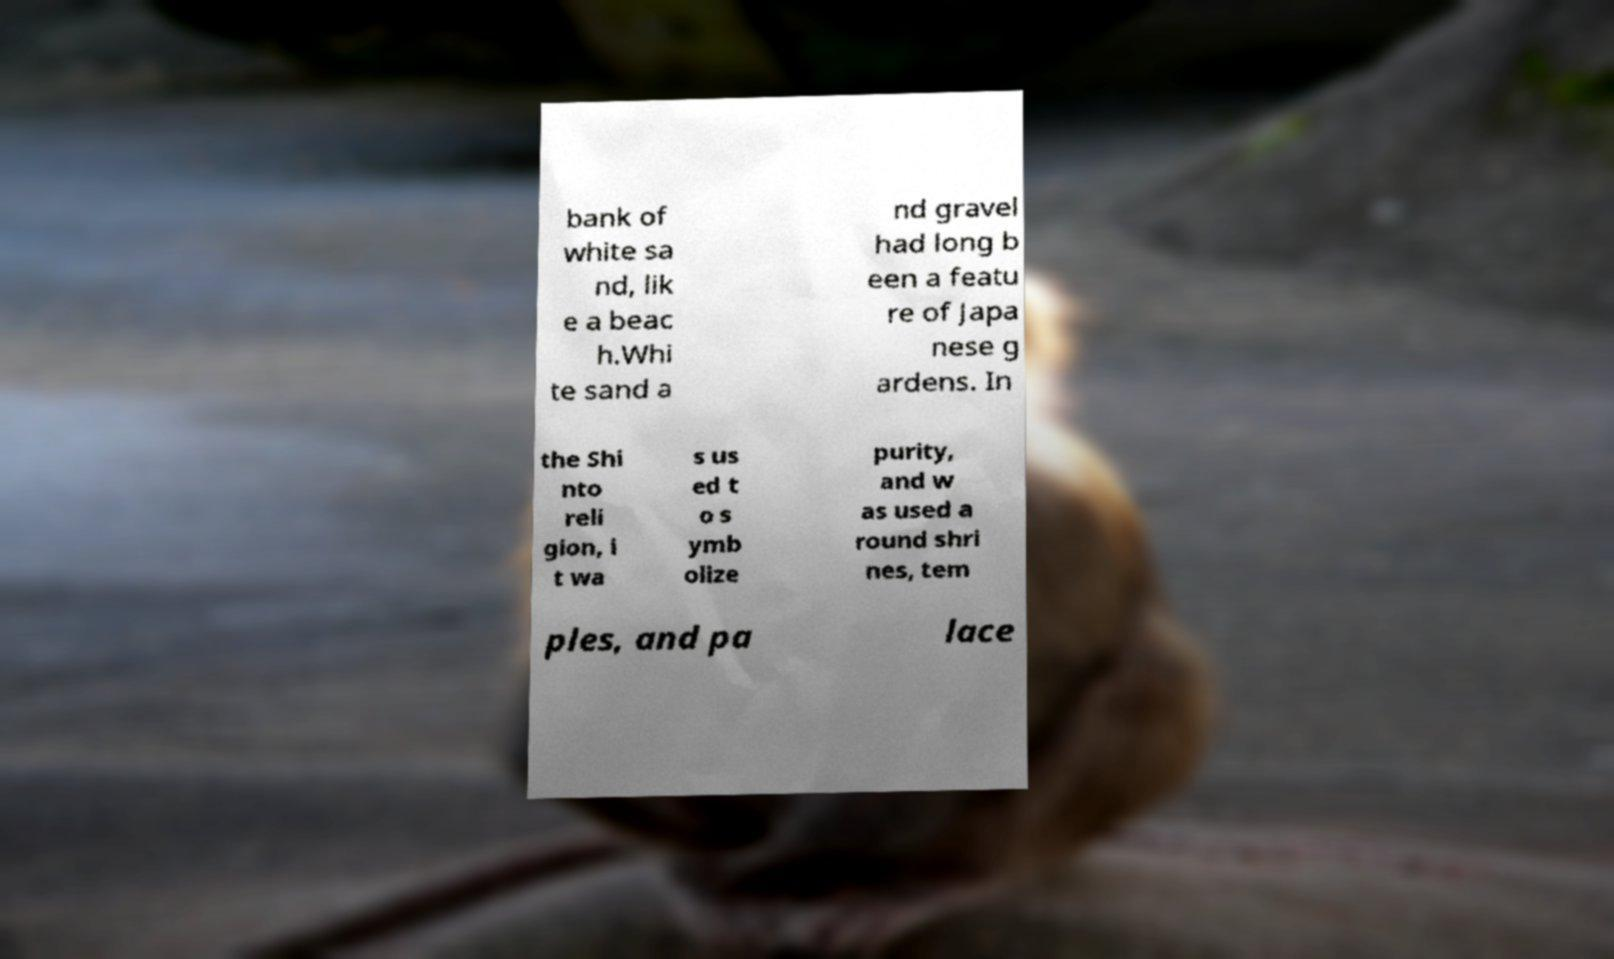What messages or text are displayed in this image? I need them in a readable, typed format. bank of white sa nd, lik e a beac h.Whi te sand a nd gravel had long b een a featu re of Japa nese g ardens. In the Shi nto reli gion, i t wa s us ed t o s ymb olize purity, and w as used a round shri nes, tem ples, and pa lace 